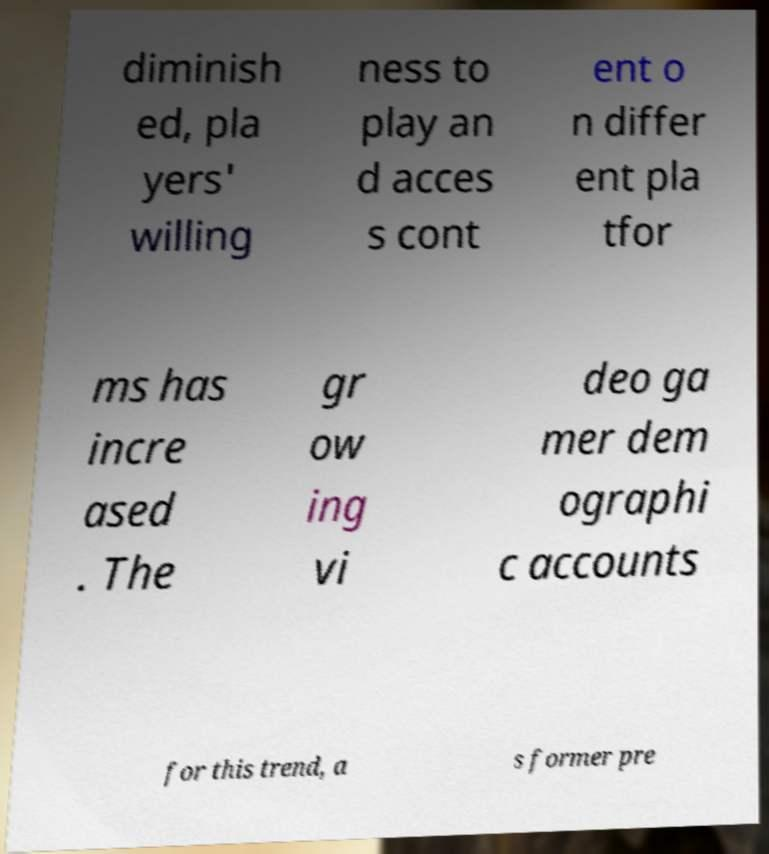For documentation purposes, I need the text within this image transcribed. Could you provide that? diminish ed, pla yers' willing ness to play an d acces s cont ent o n differ ent pla tfor ms has incre ased . The gr ow ing vi deo ga mer dem ographi c accounts for this trend, a s former pre 